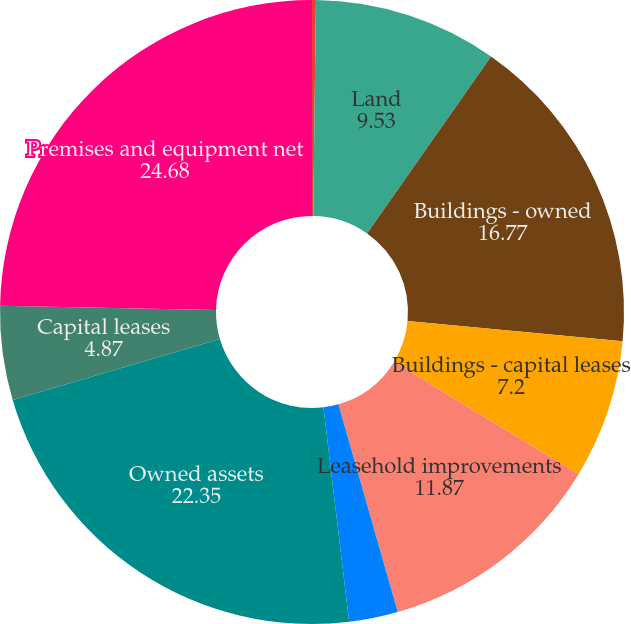Convert chart. <chart><loc_0><loc_0><loc_500><loc_500><pie_chart><fcel>In thousands<fcel>Land<fcel>Buildings - owned<fcel>Buildings - capital leases<fcel>Leasehold improvements<fcel>Furniture and equipment -<fcel>Owned assets<fcel>Capital leases<fcel>Premises and equipment net<nl><fcel>0.2%<fcel>9.53%<fcel>16.77%<fcel>7.2%<fcel>11.87%<fcel>2.53%<fcel>22.35%<fcel>4.87%<fcel>24.68%<nl></chart> 